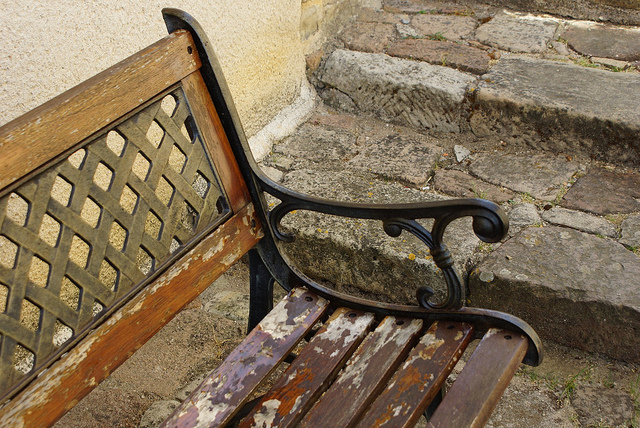Is the wood wearing off on this bench? Yes, the paint on the wooden slats of the bench is peeling and weathered, indicating signs of aging and exposure to the elements. 